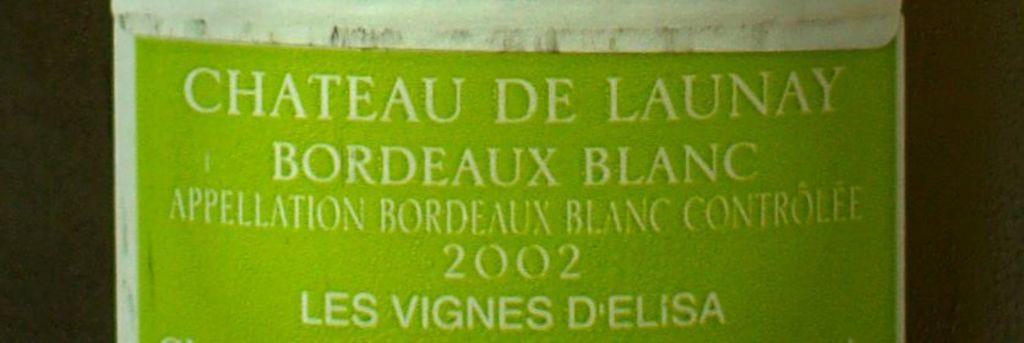<image>
Give a short and clear explanation of the subsequent image. The label for this Chateau De Launay bordeaux blanc is light green 